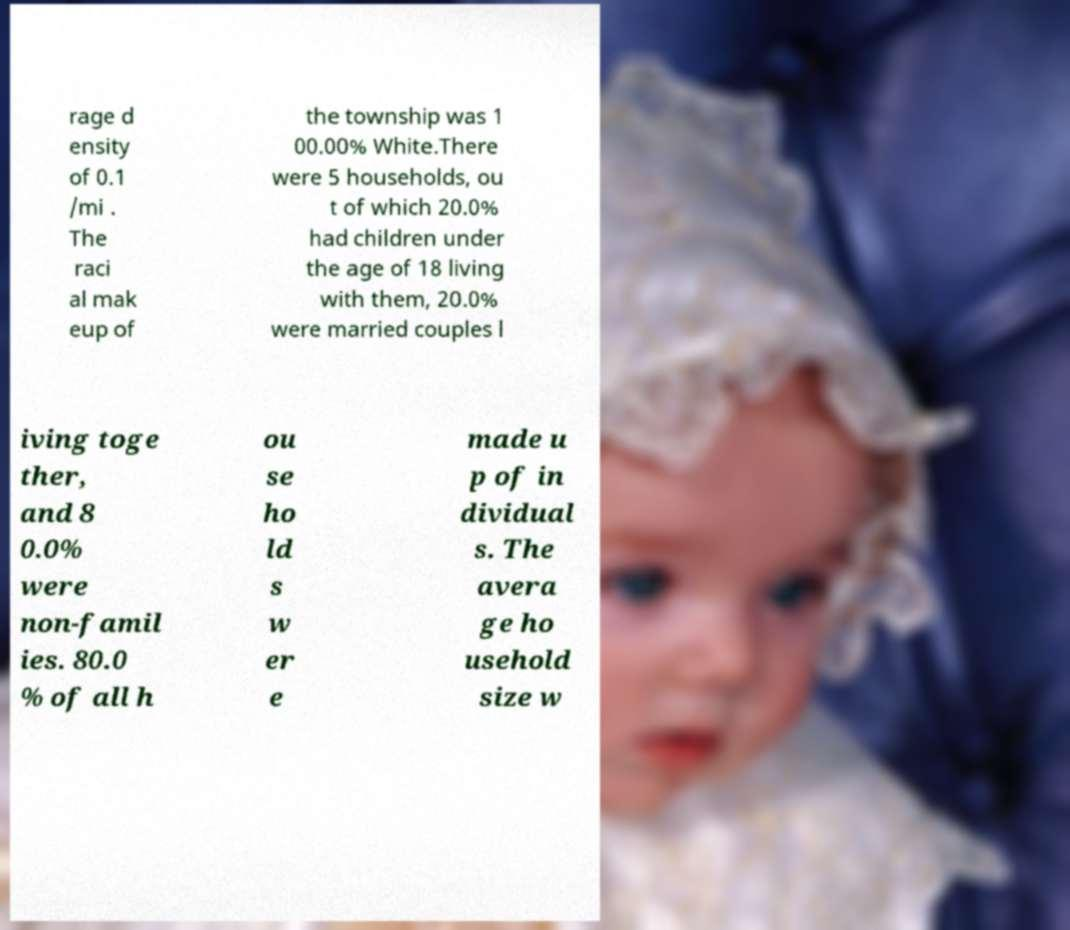Can you accurately transcribe the text from the provided image for me? rage d ensity of 0.1 /mi . The raci al mak eup of the township was 1 00.00% White.There were 5 households, ou t of which 20.0% had children under the age of 18 living with them, 20.0% were married couples l iving toge ther, and 8 0.0% were non-famil ies. 80.0 % of all h ou se ho ld s w er e made u p of in dividual s. The avera ge ho usehold size w 